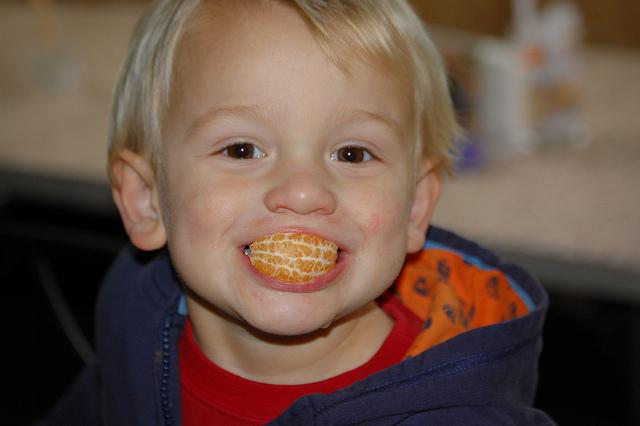Is this boy biting his lip?
Concise answer only. No. What is being eaten?
Write a very short answer. Orange. Is the boy wearing a tie?
Short answer required. No. What does the baby have in his mouth?
Quick response, please. Orange. What part of the face are these orange slices meant to represent?
Concise answer only. Mouth. What is this boy doing?
Be succinct. Smiling. What's in the baby's mouth?
Write a very short answer. Orange. What color is his hair?
Give a very brief answer. Blonde. Are both of the baby's ears visible?
Keep it brief. Yes. What is the boy eating?
Concise answer only. Orange. What color are the boy's eyes?
Give a very brief answer. Brown. What is in the child's mouth?
Quick response, please. Orange. Is the boy smiling?
Be succinct. Yes. What kind of dessert is this?
Be succinct. Orange. Is the child wearing a necklace?
Concise answer only. No. Is that an apple?
Quick response, please. No. What is the baby trying to eat?
Be succinct. Orange. What is the kid going to eat?
Give a very brief answer. Orange. What kind of fruit is the kid eating?
Give a very brief answer. Orange. Is this child eating something considered a health food?
Keep it brief. Yes. 